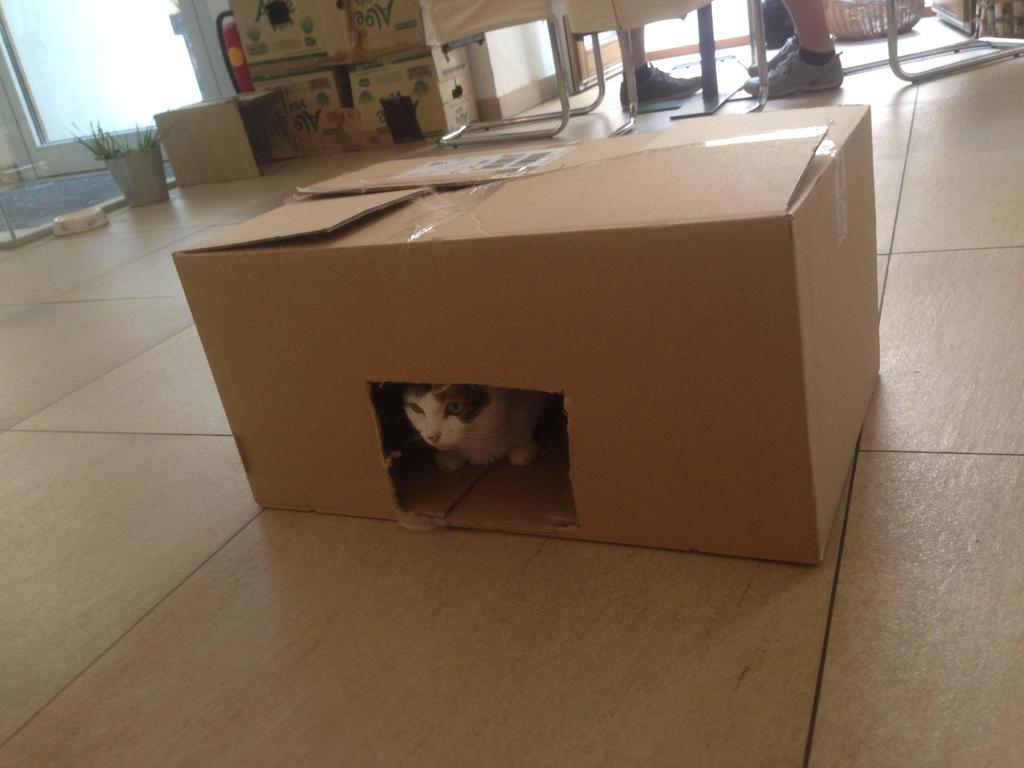What type of objects can be seen in the image? There are cardboard boxes in the image. What animal is present in the image? There is a cat in the image. What part of people can be seen in the image? People's legs are visible in the image. What type of plant is in the image? There is a houseplant in the image. Where is the door located in the image? There is a door on the left side of the image. What date is circled on the calendar in the image? There is no calendar present in the image. Why is the cat crying in the image? The cat is not crying in the image; it is simply a cat among other objects and subjects. 